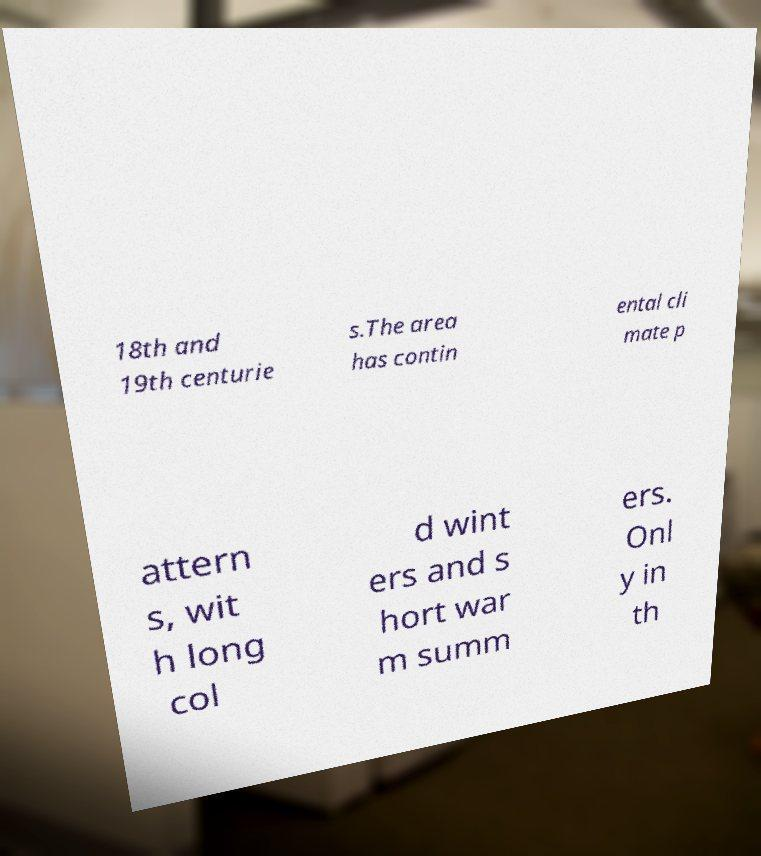What messages or text are displayed in this image? I need them in a readable, typed format. 18th and 19th centurie s.The area has contin ental cli mate p attern s, wit h long col d wint ers and s hort war m summ ers. Onl y in th 